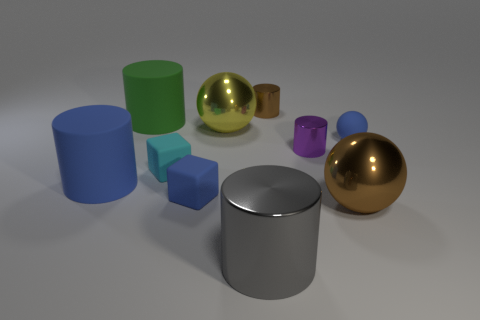Subtract all blue rubber cylinders. How many cylinders are left? 4 Subtract all purple cylinders. How many cylinders are left? 4 Subtract all cyan spheres. Subtract all cyan blocks. How many spheres are left? 3 Subtract all spheres. How many objects are left? 7 Subtract all small blue rubber objects. Subtract all gray cylinders. How many objects are left? 7 Add 3 blue matte spheres. How many blue matte spheres are left? 4 Add 2 tiny gray cubes. How many tiny gray cubes exist? 2 Subtract 0 gray blocks. How many objects are left? 10 